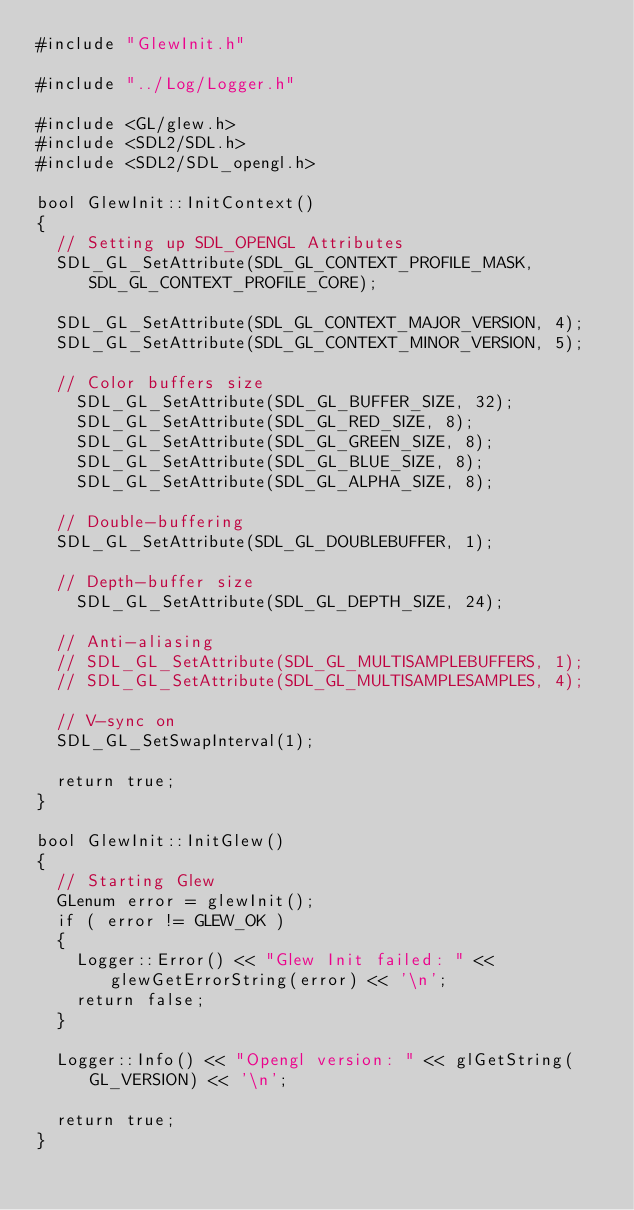Convert code to text. <code><loc_0><loc_0><loc_500><loc_500><_C++_>#include "GlewInit.h"

#include "../Log/Logger.h"

#include <GL/glew.h>
#include <SDL2/SDL.h>
#include <SDL2/SDL_opengl.h>

bool GlewInit::InitContext()
{
	// Setting up SDL_OPENGL Attributes
	SDL_GL_SetAttribute(SDL_GL_CONTEXT_PROFILE_MASK, SDL_GL_CONTEXT_PROFILE_CORE);

	SDL_GL_SetAttribute(SDL_GL_CONTEXT_MAJOR_VERSION, 4);
	SDL_GL_SetAttribute(SDL_GL_CONTEXT_MINOR_VERSION, 5);

	// Color buffers size
    SDL_GL_SetAttribute(SDL_GL_BUFFER_SIZE, 32);
    SDL_GL_SetAttribute(SDL_GL_RED_SIZE, 8);
    SDL_GL_SetAttribute(SDL_GL_GREEN_SIZE, 8);
    SDL_GL_SetAttribute(SDL_GL_BLUE_SIZE, 8);
    SDL_GL_SetAttribute(SDL_GL_ALPHA_SIZE, 8);

	// Double-buffering
	SDL_GL_SetAttribute(SDL_GL_DOUBLEBUFFER, 1);

	// Depth-buffer size
    SDL_GL_SetAttribute(SDL_GL_DEPTH_SIZE, 24);

	// Anti-aliasing
	// SDL_GL_SetAttribute(SDL_GL_MULTISAMPLEBUFFERS, 1);
	// SDL_GL_SetAttribute(SDL_GL_MULTISAMPLESAMPLES, 4);

	// V-sync on
	SDL_GL_SetSwapInterval(1);

	return true;
}

bool GlewInit::InitGlew()
{
	// Starting Glew
	GLenum error = glewInit();
	if ( error != GLEW_OK )
	{
		Logger::Error() << "Glew Init failed: " << glewGetErrorString(error) << '\n';
		return false;
	}

	Logger::Info() << "Opengl version: " << glGetString(GL_VERSION) << '\n';

	return true;
}
</code> 